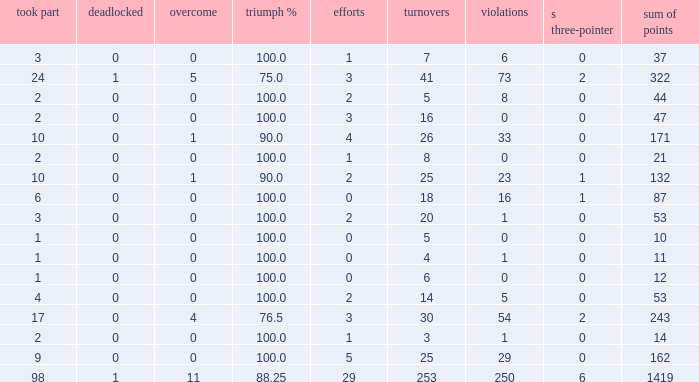How many ties did he have when he had 1 penalties and more than 20 conversions? None. 